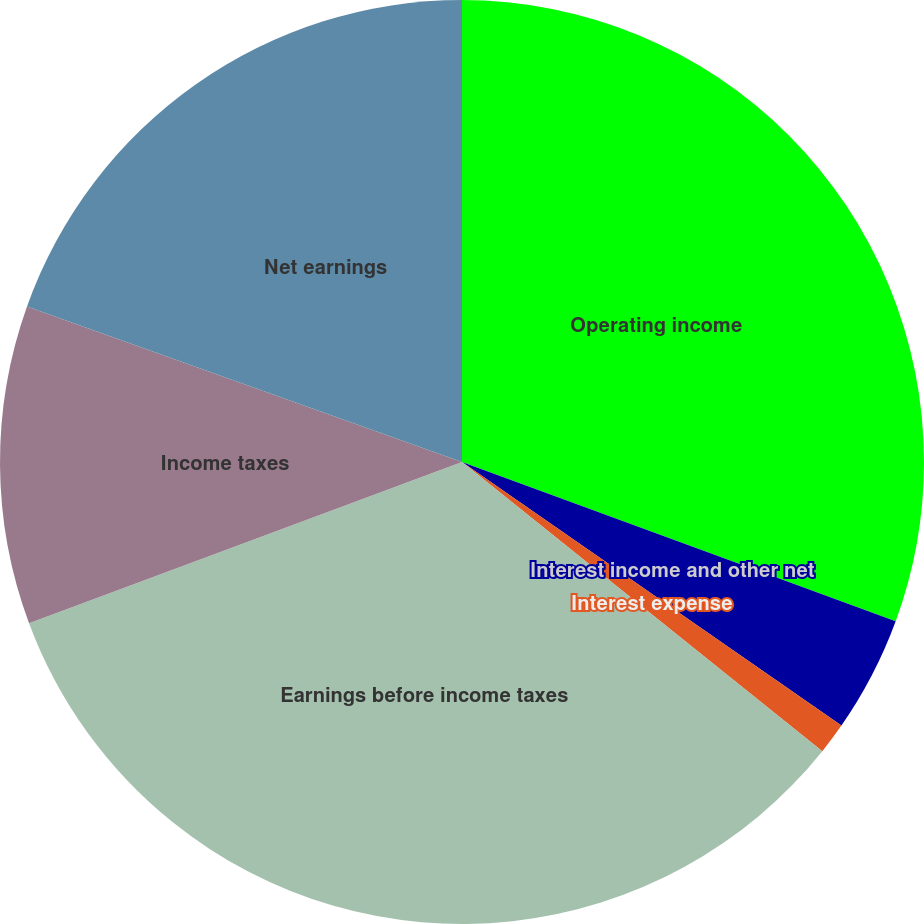<chart> <loc_0><loc_0><loc_500><loc_500><pie_chart><fcel>Operating income<fcel>Interest income and other net<fcel>Interest expense<fcel>Earnings before income taxes<fcel>Income taxes<fcel>Net earnings<nl><fcel>30.6%<fcel>4.06%<fcel>1.1%<fcel>33.56%<fcel>11.14%<fcel>19.53%<nl></chart> 